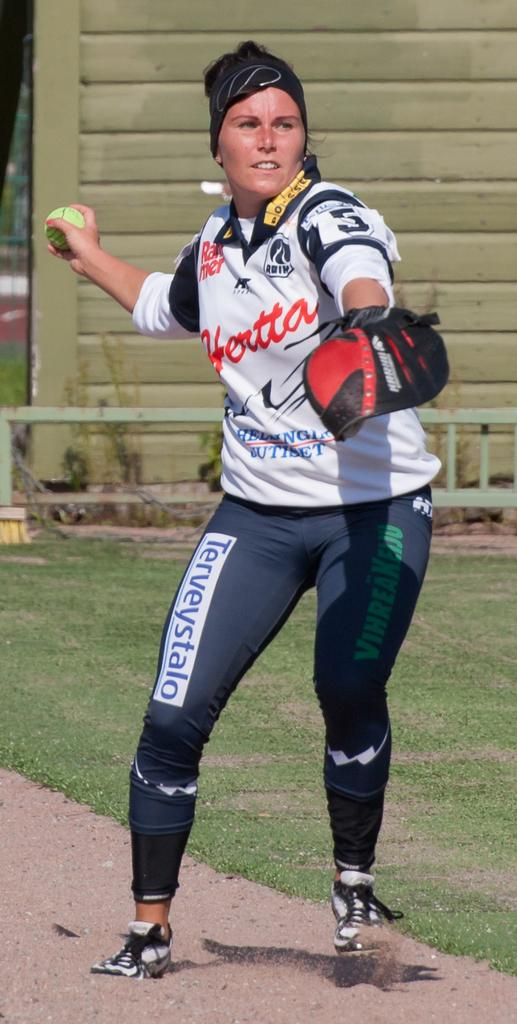<image>
Present a compact description of the photo's key features. a lady throwing a ball with hotta on it 